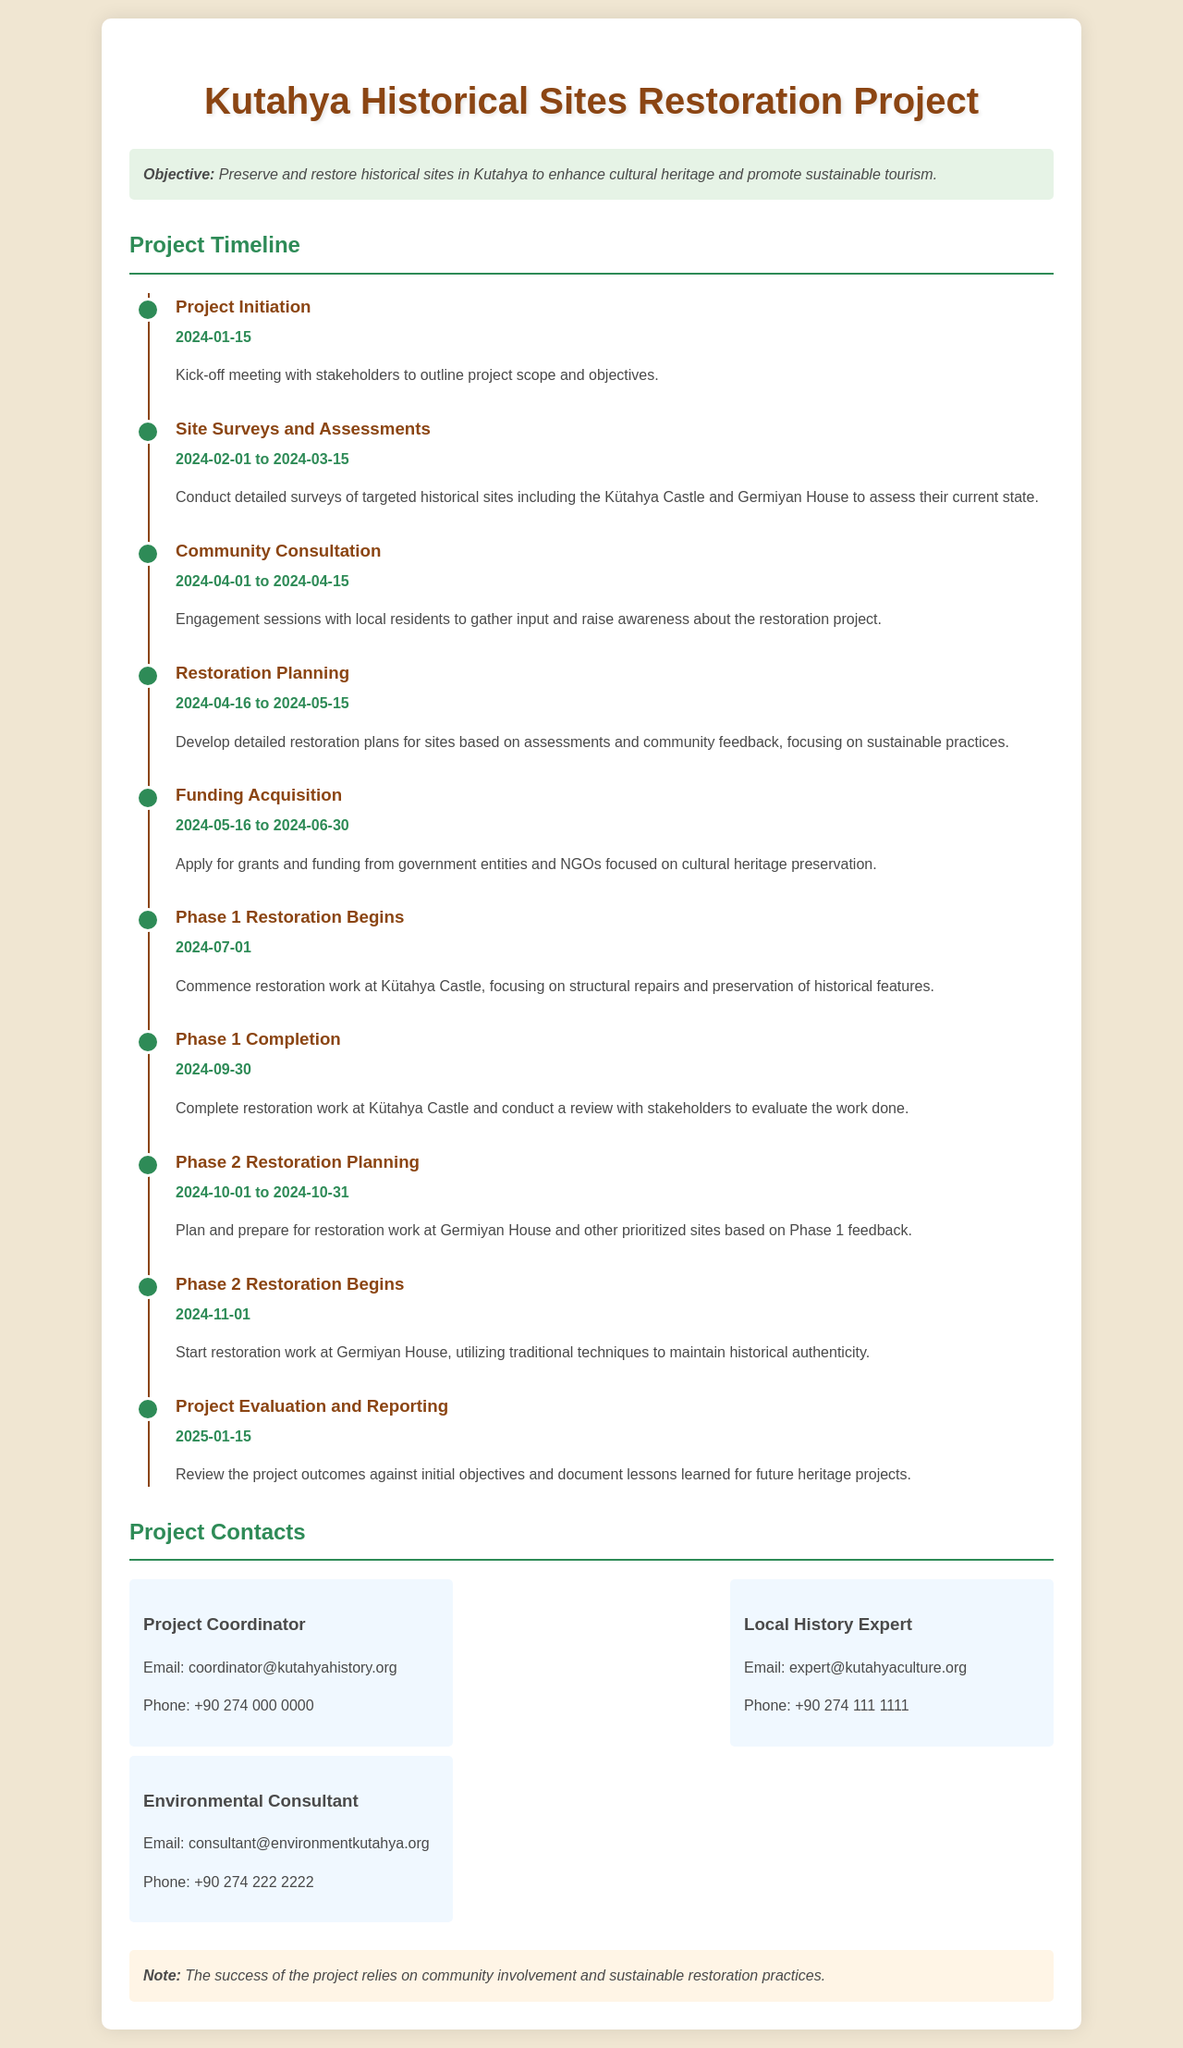What is the project's objective? The objective is to preserve and restore historical sites in Kutahya to enhance cultural heritage and promote sustainable tourism.
Answer: Preserve and restore historical sites in Kutahya When does the project initiation occur? The project initiation is marked by a kick-off meeting with stakeholders to outline project scope and objectives on the specified date.
Answer: 2024-01-15 What are the dates for site surveys and assessments? The site surveys and assessments involve conducting detailed surveys of targeted historical sites over a specific period.
Answer: 2024-02-01 to 2024-03-15 What is the focus of Phase 1 restoration? Phase 1 restoration focuses on the commencement of restoration work at a specific historical site, with a special emphasis on structural repairs.
Answer: Kütahya Castle When is the project evaluation and reporting scheduled? The project evaluation and reporting is a key milestone set for a particular date to review project outcomes.
Answer: 2025-01-15 How long is the community consultation phase? The community consultation phase includes engagement sessions with local residents within a designated timeframe.
Answer: 15 days (from 2024-04-01 to 2024-04-15) What is the method used in Phase 2 restoration? The method for Phase 2 restoration involves techniques focused on maintaining historical authenticity during the restoration.
Answer: Traditional techniques How many contacts are listed in the project? The project includes a list of essential contacts associated with different roles in the project.
Answer: 3 What is the primary engagement of the project coordinator? The role of the project coordinator is to oversee the project's progress and manage communications with stakeholders.
Answer: Communication management 